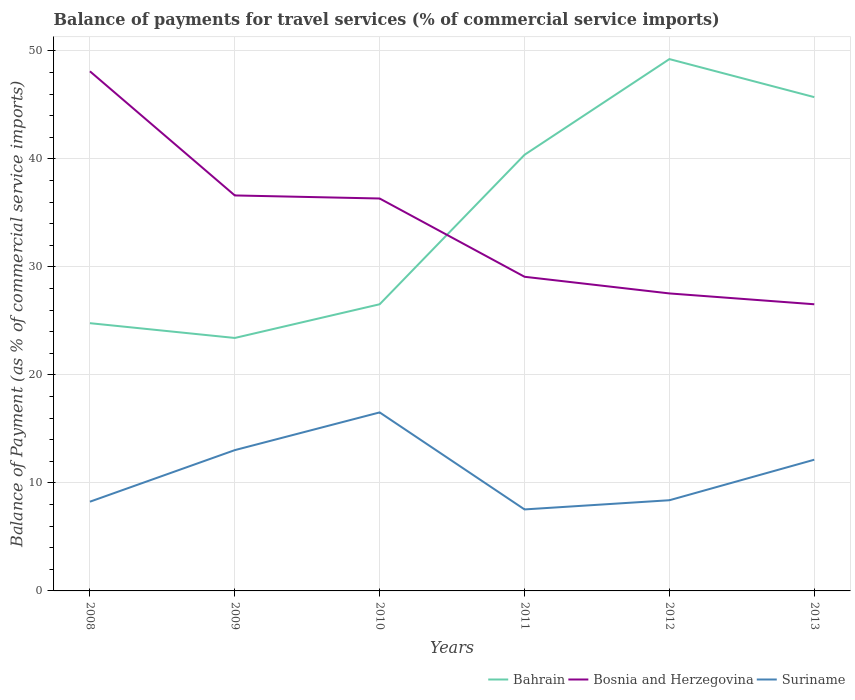Across all years, what is the maximum balance of payments for travel services in Suriname?
Keep it short and to the point. 7.54. What is the total balance of payments for travel services in Bahrain in the graph?
Ensure brevity in your answer.  -22.29. What is the difference between the highest and the second highest balance of payments for travel services in Suriname?
Provide a short and direct response. 8.98. How many lines are there?
Provide a succinct answer. 3. How many years are there in the graph?
Offer a terse response. 6. What is the difference between two consecutive major ticks on the Y-axis?
Make the answer very short. 10. Does the graph contain grids?
Provide a short and direct response. Yes. Where does the legend appear in the graph?
Your response must be concise. Bottom right. How are the legend labels stacked?
Your answer should be compact. Horizontal. What is the title of the graph?
Give a very brief answer. Balance of payments for travel services (% of commercial service imports). Does "Algeria" appear as one of the legend labels in the graph?
Ensure brevity in your answer.  No. What is the label or title of the X-axis?
Your response must be concise. Years. What is the label or title of the Y-axis?
Keep it short and to the point. Balance of Payment (as % of commercial service imports). What is the Balance of Payment (as % of commercial service imports) in Bahrain in 2008?
Provide a succinct answer. 24.79. What is the Balance of Payment (as % of commercial service imports) in Bosnia and Herzegovina in 2008?
Ensure brevity in your answer.  48.11. What is the Balance of Payment (as % of commercial service imports) of Suriname in 2008?
Offer a terse response. 8.26. What is the Balance of Payment (as % of commercial service imports) of Bahrain in 2009?
Offer a terse response. 23.42. What is the Balance of Payment (as % of commercial service imports) of Bosnia and Herzegovina in 2009?
Your answer should be compact. 36.61. What is the Balance of Payment (as % of commercial service imports) of Suriname in 2009?
Provide a succinct answer. 13.03. What is the Balance of Payment (as % of commercial service imports) of Bahrain in 2010?
Your answer should be compact. 26.54. What is the Balance of Payment (as % of commercial service imports) of Bosnia and Herzegovina in 2010?
Offer a very short reply. 36.33. What is the Balance of Payment (as % of commercial service imports) in Suriname in 2010?
Provide a succinct answer. 16.53. What is the Balance of Payment (as % of commercial service imports) of Bahrain in 2011?
Provide a succinct answer. 40.38. What is the Balance of Payment (as % of commercial service imports) in Bosnia and Herzegovina in 2011?
Ensure brevity in your answer.  29.08. What is the Balance of Payment (as % of commercial service imports) in Suriname in 2011?
Offer a terse response. 7.54. What is the Balance of Payment (as % of commercial service imports) in Bahrain in 2012?
Give a very brief answer. 49.24. What is the Balance of Payment (as % of commercial service imports) of Bosnia and Herzegovina in 2012?
Keep it short and to the point. 27.54. What is the Balance of Payment (as % of commercial service imports) of Suriname in 2012?
Offer a very short reply. 8.4. What is the Balance of Payment (as % of commercial service imports) of Bahrain in 2013?
Offer a very short reply. 45.71. What is the Balance of Payment (as % of commercial service imports) of Bosnia and Herzegovina in 2013?
Ensure brevity in your answer.  26.54. What is the Balance of Payment (as % of commercial service imports) of Suriname in 2013?
Ensure brevity in your answer.  12.15. Across all years, what is the maximum Balance of Payment (as % of commercial service imports) in Bahrain?
Offer a very short reply. 49.24. Across all years, what is the maximum Balance of Payment (as % of commercial service imports) of Bosnia and Herzegovina?
Provide a succinct answer. 48.11. Across all years, what is the maximum Balance of Payment (as % of commercial service imports) of Suriname?
Your answer should be very brief. 16.53. Across all years, what is the minimum Balance of Payment (as % of commercial service imports) in Bahrain?
Make the answer very short. 23.42. Across all years, what is the minimum Balance of Payment (as % of commercial service imports) in Bosnia and Herzegovina?
Your response must be concise. 26.54. Across all years, what is the minimum Balance of Payment (as % of commercial service imports) of Suriname?
Provide a succinct answer. 7.54. What is the total Balance of Payment (as % of commercial service imports) of Bahrain in the graph?
Make the answer very short. 210.07. What is the total Balance of Payment (as % of commercial service imports) of Bosnia and Herzegovina in the graph?
Provide a short and direct response. 204.21. What is the total Balance of Payment (as % of commercial service imports) of Suriname in the graph?
Keep it short and to the point. 65.91. What is the difference between the Balance of Payment (as % of commercial service imports) of Bahrain in 2008 and that in 2009?
Offer a very short reply. 1.37. What is the difference between the Balance of Payment (as % of commercial service imports) in Bosnia and Herzegovina in 2008 and that in 2009?
Make the answer very short. 11.49. What is the difference between the Balance of Payment (as % of commercial service imports) of Suriname in 2008 and that in 2009?
Provide a short and direct response. -4.77. What is the difference between the Balance of Payment (as % of commercial service imports) of Bahrain in 2008 and that in 2010?
Your answer should be very brief. -1.75. What is the difference between the Balance of Payment (as % of commercial service imports) in Bosnia and Herzegovina in 2008 and that in 2010?
Your answer should be compact. 11.78. What is the difference between the Balance of Payment (as % of commercial service imports) of Suriname in 2008 and that in 2010?
Your answer should be very brief. -8.27. What is the difference between the Balance of Payment (as % of commercial service imports) in Bahrain in 2008 and that in 2011?
Provide a short and direct response. -15.59. What is the difference between the Balance of Payment (as % of commercial service imports) in Bosnia and Herzegovina in 2008 and that in 2011?
Give a very brief answer. 19.02. What is the difference between the Balance of Payment (as % of commercial service imports) in Suriname in 2008 and that in 2011?
Your response must be concise. 0.72. What is the difference between the Balance of Payment (as % of commercial service imports) of Bahrain in 2008 and that in 2012?
Make the answer very short. -24.45. What is the difference between the Balance of Payment (as % of commercial service imports) in Bosnia and Herzegovina in 2008 and that in 2012?
Your response must be concise. 20.56. What is the difference between the Balance of Payment (as % of commercial service imports) of Suriname in 2008 and that in 2012?
Offer a very short reply. -0.13. What is the difference between the Balance of Payment (as % of commercial service imports) of Bahrain in 2008 and that in 2013?
Your answer should be compact. -20.93. What is the difference between the Balance of Payment (as % of commercial service imports) in Bosnia and Herzegovina in 2008 and that in 2013?
Your response must be concise. 21.57. What is the difference between the Balance of Payment (as % of commercial service imports) of Suriname in 2008 and that in 2013?
Provide a short and direct response. -3.89. What is the difference between the Balance of Payment (as % of commercial service imports) of Bahrain in 2009 and that in 2010?
Give a very brief answer. -3.12. What is the difference between the Balance of Payment (as % of commercial service imports) of Bosnia and Herzegovina in 2009 and that in 2010?
Give a very brief answer. 0.28. What is the difference between the Balance of Payment (as % of commercial service imports) in Suriname in 2009 and that in 2010?
Ensure brevity in your answer.  -3.49. What is the difference between the Balance of Payment (as % of commercial service imports) of Bahrain in 2009 and that in 2011?
Your answer should be very brief. -16.96. What is the difference between the Balance of Payment (as % of commercial service imports) of Bosnia and Herzegovina in 2009 and that in 2011?
Your answer should be very brief. 7.53. What is the difference between the Balance of Payment (as % of commercial service imports) of Suriname in 2009 and that in 2011?
Give a very brief answer. 5.49. What is the difference between the Balance of Payment (as % of commercial service imports) of Bahrain in 2009 and that in 2012?
Your answer should be very brief. -25.82. What is the difference between the Balance of Payment (as % of commercial service imports) of Bosnia and Herzegovina in 2009 and that in 2012?
Ensure brevity in your answer.  9.07. What is the difference between the Balance of Payment (as % of commercial service imports) of Suriname in 2009 and that in 2012?
Your response must be concise. 4.64. What is the difference between the Balance of Payment (as % of commercial service imports) in Bahrain in 2009 and that in 2013?
Your answer should be compact. -22.29. What is the difference between the Balance of Payment (as % of commercial service imports) in Bosnia and Herzegovina in 2009 and that in 2013?
Keep it short and to the point. 10.07. What is the difference between the Balance of Payment (as % of commercial service imports) in Suriname in 2009 and that in 2013?
Provide a short and direct response. 0.89. What is the difference between the Balance of Payment (as % of commercial service imports) in Bahrain in 2010 and that in 2011?
Offer a terse response. -13.84. What is the difference between the Balance of Payment (as % of commercial service imports) of Bosnia and Herzegovina in 2010 and that in 2011?
Make the answer very short. 7.25. What is the difference between the Balance of Payment (as % of commercial service imports) in Suriname in 2010 and that in 2011?
Make the answer very short. 8.98. What is the difference between the Balance of Payment (as % of commercial service imports) of Bahrain in 2010 and that in 2012?
Provide a short and direct response. -22.7. What is the difference between the Balance of Payment (as % of commercial service imports) in Bosnia and Herzegovina in 2010 and that in 2012?
Ensure brevity in your answer.  8.79. What is the difference between the Balance of Payment (as % of commercial service imports) of Suriname in 2010 and that in 2012?
Provide a short and direct response. 8.13. What is the difference between the Balance of Payment (as % of commercial service imports) in Bahrain in 2010 and that in 2013?
Offer a very short reply. -19.17. What is the difference between the Balance of Payment (as % of commercial service imports) in Bosnia and Herzegovina in 2010 and that in 2013?
Provide a short and direct response. 9.79. What is the difference between the Balance of Payment (as % of commercial service imports) in Suriname in 2010 and that in 2013?
Your answer should be compact. 4.38. What is the difference between the Balance of Payment (as % of commercial service imports) of Bahrain in 2011 and that in 2012?
Provide a succinct answer. -8.86. What is the difference between the Balance of Payment (as % of commercial service imports) of Bosnia and Herzegovina in 2011 and that in 2012?
Your response must be concise. 1.54. What is the difference between the Balance of Payment (as % of commercial service imports) of Suriname in 2011 and that in 2012?
Make the answer very short. -0.85. What is the difference between the Balance of Payment (as % of commercial service imports) in Bahrain in 2011 and that in 2013?
Make the answer very short. -5.34. What is the difference between the Balance of Payment (as % of commercial service imports) in Bosnia and Herzegovina in 2011 and that in 2013?
Offer a very short reply. 2.55. What is the difference between the Balance of Payment (as % of commercial service imports) of Suriname in 2011 and that in 2013?
Make the answer very short. -4.6. What is the difference between the Balance of Payment (as % of commercial service imports) in Bahrain in 2012 and that in 2013?
Your answer should be compact. 3.52. What is the difference between the Balance of Payment (as % of commercial service imports) of Suriname in 2012 and that in 2013?
Make the answer very short. -3.75. What is the difference between the Balance of Payment (as % of commercial service imports) of Bahrain in 2008 and the Balance of Payment (as % of commercial service imports) of Bosnia and Herzegovina in 2009?
Ensure brevity in your answer.  -11.83. What is the difference between the Balance of Payment (as % of commercial service imports) of Bahrain in 2008 and the Balance of Payment (as % of commercial service imports) of Suriname in 2009?
Ensure brevity in your answer.  11.75. What is the difference between the Balance of Payment (as % of commercial service imports) of Bosnia and Herzegovina in 2008 and the Balance of Payment (as % of commercial service imports) of Suriname in 2009?
Offer a terse response. 35.07. What is the difference between the Balance of Payment (as % of commercial service imports) of Bahrain in 2008 and the Balance of Payment (as % of commercial service imports) of Bosnia and Herzegovina in 2010?
Your answer should be compact. -11.54. What is the difference between the Balance of Payment (as % of commercial service imports) in Bahrain in 2008 and the Balance of Payment (as % of commercial service imports) in Suriname in 2010?
Your answer should be very brief. 8.26. What is the difference between the Balance of Payment (as % of commercial service imports) of Bosnia and Herzegovina in 2008 and the Balance of Payment (as % of commercial service imports) of Suriname in 2010?
Provide a short and direct response. 31.58. What is the difference between the Balance of Payment (as % of commercial service imports) of Bahrain in 2008 and the Balance of Payment (as % of commercial service imports) of Bosnia and Herzegovina in 2011?
Make the answer very short. -4.3. What is the difference between the Balance of Payment (as % of commercial service imports) of Bahrain in 2008 and the Balance of Payment (as % of commercial service imports) of Suriname in 2011?
Offer a very short reply. 17.24. What is the difference between the Balance of Payment (as % of commercial service imports) of Bosnia and Herzegovina in 2008 and the Balance of Payment (as % of commercial service imports) of Suriname in 2011?
Keep it short and to the point. 40.56. What is the difference between the Balance of Payment (as % of commercial service imports) in Bahrain in 2008 and the Balance of Payment (as % of commercial service imports) in Bosnia and Herzegovina in 2012?
Offer a terse response. -2.75. What is the difference between the Balance of Payment (as % of commercial service imports) in Bahrain in 2008 and the Balance of Payment (as % of commercial service imports) in Suriname in 2012?
Provide a short and direct response. 16.39. What is the difference between the Balance of Payment (as % of commercial service imports) in Bosnia and Herzegovina in 2008 and the Balance of Payment (as % of commercial service imports) in Suriname in 2012?
Offer a terse response. 39.71. What is the difference between the Balance of Payment (as % of commercial service imports) of Bahrain in 2008 and the Balance of Payment (as % of commercial service imports) of Bosnia and Herzegovina in 2013?
Offer a terse response. -1.75. What is the difference between the Balance of Payment (as % of commercial service imports) in Bahrain in 2008 and the Balance of Payment (as % of commercial service imports) in Suriname in 2013?
Ensure brevity in your answer.  12.64. What is the difference between the Balance of Payment (as % of commercial service imports) in Bosnia and Herzegovina in 2008 and the Balance of Payment (as % of commercial service imports) in Suriname in 2013?
Provide a succinct answer. 35.96. What is the difference between the Balance of Payment (as % of commercial service imports) in Bahrain in 2009 and the Balance of Payment (as % of commercial service imports) in Bosnia and Herzegovina in 2010?
Provide a short and direct response. -12.91. What is the difference between the Balance of Payment (as % of commercial service imports) of Bahrain in 2009 and the Balance of Payment (as % of commercial service imports) of Suriname in 2010?
Provide a short and direct response. 6.89. What is the difference between the Balance of Payment (as % of commercial service imports) in Bosnia and Herzegovina in 2009 and the Balance of Payment (as % of commercial service imports) in Suriname in 2010?
Your answer should be compact. 20.09. What is the difference between the Balance of Payment (as % of commercial service imports) in Bahrain in 2009 and the Balance of Payment (as % of commercial service imports) in Bosnia and Herzegovina in 2011?
Offer a terse response. -5.67. What is the difference between the Balance of Payment (as % of commercial service imports) in Bahrain in 2009 and the Balance of Payment (as % of commercial service imports) in Suriname in 2011?
Provide a short and direct response. 15.87. What is the difference between the Balance of Payment (as % of commercial service imports) of Bosnia and Herzegovina in 2009 and the Balance of Payment (as % of commercial service imports) of Suriname in 2011?
Provide a short and direct response. 29.07. What is the difference between the Balance of Payment (as % of commercial service imports) of Bahrain in 2009 and the Balance of Payment (as % of commercial service imports) of Bosnia and Herzegovina in 2012?
Give a very brief answer. -4.12. What is the difference between the Balance of Payment (as % of commercial service imports) in Bahrain in 2009 and the Balance of Payment (as % of commercial service imports) in Suriname in 2012?
Your answer should be very brief. 15.02. What is the difference between the Balance of Payment (as % of commercial service imports) in Bosnia and Herzegovina in 2009 and the Balance of Payment (as % of commercial service imports) in Suriname in 2012?
Offer a very short reply. 28.22. What is the difference between the Balance of Payment (as % of commercial service imports) of Bahrain in 2009 and the Balance of Payment (as % of commercial service imports) of Bosnia and Herzegovina in 2013?
Make the answer very short. -3.12. What is the difference between the Balance of Payment (as % of commercial service imports) in Bahrain in 2009 and the Balance of Payment (as % of commercial service imports) in Suriname in 2013?
Ensure brevity in your answer.  11.27. What is the difference between the Balance of Payment (as % of commercial service imports) in Bosnia and Herzegovina in 2009 and the Balance of Payment (as % of commercial service imports) in Suriname in 2013?
Your response must be concise. 24.47. What is the difference between the Balance of Payment (as % of commercial service imports) in Bahrain in 2010 and the Balance of Payment (as % of commercial service imports) in Bosnia and Herzegovina in 2011?
Your answer should be compact. -2.54. What is the difference between the Balance of Payment (as % of commercial service imports) in Bahrain in 2010 and the Balance of Payment (as % of commercial service imports) in Suriname in 2011?
Make the answer very short. 18.99. What is the difference between the Balance of Payment (as % of commercial service imports) in Bosnia and Herzegovina in 2010 and the Balance of Payment (as % of commercial service imports) in Suriname in 2011?
Provide a short and direct response. 28.78. What is the difference between the Balance of Payment (as % of commercial service imports) of Bahrain in 2010 and the Balance of Payment (as % of commercial service imports) of Bosnia and Herzegovina in 2012?
Offer a very short reply. -1. What is the difference between the Balance of Payment (as % of commercial service imports) in Bahrain in 2010 and the Balance of Payment (as % of commercial service imports) in Suriname in 2012?
Ensure brevity in your answer.  18.14. What is the difference between the Balance of Payment (as % of commercial service imports) of Bosnia and Herzegovina in 2010 and the Balance of Payment (as % of commercial service imports) of Suriname in 2012?
Make the answer very short. 27.93. What is the difference between the Balance of Payment (as % of commercial service imports) of Bahrain in 2010 and the Balance of Payment (as % of commercial service imports) of Bosnia and Herzegovina in 2013?
Your answer should be compact. 0. What is the difference between the Balance of Payment (as % of commercial service imports) of Bahrain in 2010 and the Balance of Payment (as % of commercial service imports) of Suriname in 2013?
Make the answer very short. 14.39. What is the difference between the Balance of Payment (as % of commercial service imports) of Bosnia and Herzegovina in 2010 and the Balance of Payment (as % of commercial service imports) of Suriname in 2013?
Offer a terse response. 24.18. What is the difference between the Balance of Payment (as % of commercial service imports) of Bahrain in 2011 and the Balance of Payment (as % of commercial service imports) of Bosnia and Herzegovina in 2012?
Make the answer very short. 12.84. What is the difference between the Balance of Payment (as % of commercial service imports) in Bahrain in 2011 and the Balance of Payment (as % of commercial service imports) in Suriname in 2012?
Provide a succinct answer. 31.98. What is the difference between the Balance of Payment (as % of commercial service imports) of Bosnia and Herzegovina in 2011 and the Balance of Payment (as % of commercial service imports) of Suriname in 2012?
Your answer should be compact. 20.69. What is the difference between the Balance of Payment (as % of commercial service imports) in Bahrain in 2011 and the Balance of Payment (as % of commercial service imports) in Bosnia and Herzegovina in 2013?
Your answer should be very brief. 13.84. What is the difference between the Balance of Payment (as % of commercial service imports) in Bahrain in 2011 and the Balance of Payment (as % of commercial service imports) in Suriname in 2013?
Ensure brevity in your answer.  28.23. What is the difference between the Balance of Payment (as % of commercial service imports) of Bosnia and Herzegovina in 2011 and the Balance of Payment (as % of commercial service imports) of Suriname in 2013?
Ensure brevity in your answer.  16.94. What is the difference between the Balance of Payment (as % of commercial service imports) of Bahrain in 2012 and the Balance of Payment (as % of commercial service imports) of Bosnia and Herzegovina in 2013?
Provide a short and direct response. 22.7. What is the difference between the Balance of Payment (as % of commercial service imports) in Bahrain in 2012 and the Balance of Payment (as % of commercial service imports) in Suriname in 2013?
Provide a short and direct response. 37.09. What is the difference between the Balance of Payment (as % of commercial service imports) of Bosnia and Herzegovina in 2012 and the Balance of Payment (as % of commercial service imports) of Suriname in 2013?
Make the answer very short. 15.39. What is the average Balance of Payment (as % of commercial service imports) of Bahrain per year?
Your answer should be compact. 35.01. What is the average Balance of Payment (as % of commercial service imports) of Bosnia and Herzegovina per year?
Ensure brevity in your answer.  34.04. What is the average Balance of Payment (as % of commercial service imports) of Suriname per year?
Ensure brevity in your answer.  10.98. In the year 2008, what is the difference between the Balance of Payment (as % of commercial service imports) in Bahrain and Balance of Payment (as % of commercial service imports) in Bosnia and Herzegovina?
Provide a short and direct response. -23.32. In the year 2008, what is the difference between the Balance of Payment (as % of commercial service imports) of Bahrain and Balance of Payment (as % of commercial service imports) of Suriname?
Your answer should be very brief. 16.53. In the year 2008, what is the difference between the Balance of Payment (as % of commercial service imports) of Bosnia and Herzegovina and Balance of Payment (as % of commercial service imports) of Suriname?
Provide a short and direct response. 39.85. In the year 2009, what is the difference between the Balance of Payment (as % of commercial service imports) in Bahrain and Balance of Payment (as % of commercial service imports) in Bosnia and Herzegovina?
Keep it short and to the point. -13.19. In the year 2009, what is the difference between the Balance of Payment (as % of commercial service imports) of Bahrain and Balance of Payment (as % of commercial service imports) of Suriname?
Your response must be concise. 10.38. In the year 2009, what is the difference between the Balance of Payment (as % of commercial service imports) in Bosnia and Herzegovina and Balance of Payment (as % of commercial service imports) in Suriname?
Make the answer very short. 23.58. In the year 2010, what is the difference between the Balance of Payment (as % of commercial service imports) in Bahrain and Balance of Payment (as % of commercial service imports) in Bosnia and Herzegovina?
Make the answer very short. -9.79. In the year 2010, what is the difference between the Balance of Payment (as % of commercial service imports) in Bahrain and Balance of Payment (as % of commercial service imports) in Suriname?
Your answer should be compact. 10.01. In the year 2010, what is the difference between the Balance of Payment (as % of commercial service imports) of Bosnia and Herzegovina and Balance of Payment (as % of commercial service imports) of Suriname?
Offer a very short reply. 19.8. In the year 2011, what is the difference between the Balance of Payment (as % of commercial service imports) of Bahrain and Balance of Payment (as % of commercial service imports) of Bosnia and Herzegovina?
Make the answer very short. 11.29. In the year 2011, what is the difference between the Balance of Payment (as % of commercial service imports) in Bahrain and Balance of Payment (as % of commercial service imports) in Suriname?
Your answer should be compact. 32.83. In the year 2011, what is the difference between the Balance of Payment (as % of commercial service imports) of Bosnia and Herzegovina and Balance of Payment (as % of commercial service imports) of Suriname?
Provide a short and direct response. 21.54. In the year 2012, what is the difference between the Balance of Payment (as % of commercial service imports) in Bahrain and Balance of Payment (as % of commercial service imports) in Bosnia and Herzegovina?
Offer a terse response. 21.69. In the year 2012, what is the difference between the Balance of Payment (as % of commercial service imports) of Bahrain and Balance of Payment (as % of commercial service imports) of Suriname?
Offer a very short reply. 40.84. In the year 2012, what is the difference between the Balance of Payment (as % of commercial service imports) in Bosnia and Herzegovina and Balance of Payment (as % of commercial service imports) in Suriname?
Provide a succinct answer. 19.15. In the year 2013, what is the difference between the Balance of Payment (as % of commercial service imports) in Bahrain and Balance of Payment (as % of commercial service imports) in Bosnia and Herzegovina?
Your answer should be very brief. 19.17. In the year 2013, what is the difference between the Balance of Payment (as % of commercial service imports) of Bahrain and Balance of Payment (as % of commercial service imports) of Suriname?
Your response must be concise. 33.57. In the year 2013, what is the difference between the Balance of Payment (as % of commercial service imports) in Bosnia and Herzegovina and Balance of Payment (as % of commercial service imports) in Suriname?
Provide a short and direct response. 14.39. What is the ratio of the Balance of Payment (as % of commercial service imports) in Bahrain in 2008 to that in 2009?
Your answer should be compact. 1.06. What is the ratio of the Balance of Payment (as % of commercial service imports) of Bosnia and Herzegovina in 2008 to that in 2009?
Your answer should be compact. 1.31. What is the ratio of the Balance of Payment (as % of commercial service imports) in Suriname in 2008 to that in 2009?
Ensure brevity in your answer.  0.63. What is the ratio of the Balance of Payment (as % of commercial service imports) of Bahrain in 2008 to that in 2010?
Your answer should be compact. 0.93. What is the ratio of the Balance of Payment (as % of commercial service imports) in Bosnia and Herzegovina in 2008 to that in 2010?
Provide a short and direct response. 1.32. What is the ratio of the Balance of Payment (as % of commercial service imports) in Suriname in 2008 to that in 2010?
Make the answer very short. 0.5. What is the ratio of the Balance of Payment (as % of commercial service imports) of Bahrain in 2008 to that in 2011?
Ensure brevity in your answer.  0.61. What is the ratio of the Balance of Payment (as % of commercial service imports) of Bosnia and Herzegovina in 2008 to that in 2011?
Ensure brevity in your answer.  1.65. What is the ratio of the Balance of Payment (as % of commercial service imports) in Suriname in 2008 to that in 2011?
Make the answer very short. 1.09. What is the ratio of the Balance of Payment (as % of commercial service imports) in Bahrain in 2008 to that in 2012?
Give a very brief answer. 0.5. What is the ratio of the Balance of Payment (as % of commercial service imports) of Bosnia and Herzegovina in 2008 to that in 2012?
Give a very brief answer. 1.75. What is the ratio of the Balance of Payment (as % of commercial service imports) in Suriname in 2008 to that in 2012?
Your answer should be very brief. 0.98. What is the ratio of the Balance of Payment (as % of commercial service imports) in Bahrain in 2008 to that in 2013?
Your response must be concise. 0.54. What is the ratio of the Balance of Payment (as % of commercial service imports) of Bosnia and Herzegovina in 2008 to that in 2013?
Your answer should be compact. 1.81. What is the ratio of the Balance of Payment (as % of commercial service imports) in Suriname in 2008 to that in 2013?
Keep it short and to the point. 0.68. What is the ratio of the Balance of Payment (as % of commercial service imports) in Bahrain in 2009 to that in 2010?
Keep it short and to the point. 0.88. What is the ratio of the Balance of Payment (as % of commercial service imports) in Suriname in 2009 to that in 2010?
Your response must be concise. 0.79. What is the ratio of the Balance of Payment (as % of commercial service imports) in Bahrain in 2009 to that in 2011?
Provide a succinct answer. 0.58. What is the ratio of the Balance of Payment (as % of commercial service imports) of Bosnia and Herzegovina in 2009 to that in 2011?
Keep it short and to the point. 1.26. What is the ratio of the Balance of Payment (as % of commercial service imports) of Suriname in 2009 to that in 2011?
Keep it short and to the point. 1.73. What is the ratio of the Balance of Payment (as % of commercial service imports) of Bahrain in 2009 to that in 2012?
Give a very brief answer. 0.48. What is the ratio of the Balance of Payment (as % of commercial service imports) in Bosnia and Herzegovina in 2009 to that in 2012?
Make the answer very short. 1.33. What is the ratio of the Balance of Payment (as % of commercial service imports) of Suriname in 2009 to that in 2012?
Your answer should be very brief. 1.55. What is the ratio of the Balance of Payment (as % of commercial service imports) of Bahrain in 2009 to that in 2013?
Your answer should be compact. 0.51. What is the ratio of the Balance of Payment (as % of commercial service imports) in Bosnia and Herzegovina in 2009 to that in 2013?
Make the answer very short. 1.38. What is the ratio of the Balance of Payment (as % of commercial service imports) of Suriname in 2009 to that in 2013?
Make the answer very short. 1.07. What is the ratio of the Balance of Payment (as % of commercial service imports) of Bahrain in 2010 to that in 2011?
Provide a succinct answer. 0.66. What is the ratio of the Balance of Payment (as % of commercial service imports) of Bosnia and Herzegovina in 2010 to that in 2011?
Your response must be concise. 1.25. What is the ratio of the Balance of Payment (as % of commercial service imports) in Suriname in 2010 to that in 2011?
Ensure brevity in your answer.  2.19. What is the ratio of the Balance of Payment (as % of commercial service imports) in Bahrain in 2010 to that in 2012?
Make the answer very short. 0.54. What is the ratio of the Balance of Payment (as % of commercial service imports) in Bosnia and Herzegovina in 2010 to that in 2012?
Keep it short and to the point. 1.32. What is the ratio of the Balance of Payment (as % of commercial service imports) of Suriname in 2010 to that in 2012?
Keep it short and to the point. 1.97. What is the ratio of the Balance of Payment (as % of commercial service imports) in Bahrain in 2010 to that in 2013?
Provide a short and direct response. 0.58. What is the ratio of the Balance of Payment (as % of commercial service imports) in Bosnia and Herzegovina in 2010 to that in 2013?
Your response must be concise. 1.37. What is the ratio of the Balance of Payment (as % of commercial service imports) in Suriname in 2010 to that in 2013?
Your response must be concise. 1.36. What is the ratio of the Balance of Payment (as % of commercial service imports) of Bahrain in 2011 to that in 2012?
Offer a very short reply. 0.82. What is the ratio of the Balance of Payment (as % of commercial service imports) in Bosnia and Herzegovina in 2011 to that in 2012?
Provide a succinct answer. 1.06. What is the ratio of the Balance of Payment (as % of commercial service imports) in Suriname in 2011 to that in 2012?
Ensure brevity in your answer.  0.9. What is the ratio of the Balance of Payment (as % of commercial service imports) in Bahrain in 2011 to that in 2013?
Give a very brief answer. 0.88. What is the ratio of the Balance of Payment (as % of commercial service imports) of Bosnia and Herzegovina in 2011 to that in 2013?
Ensure brevity in your answer.  1.1. What is the ratio of the Balance of Payment (as % of commercial service imports) in Suriname in 2011 to that in 2013?
Your answer should be very brief. 0.62. What is the ratio of the Balance of Payment (as % of commercial service imports) of Bahrain in 2012 to that in 2013?
Your answer should be very brief. 1.08. What is the ratio of the Balance of Payment (as % of commercial service imports) of Bosnia and Herzegovina in 2012 to that in 2013?
Provide a short and direct response. 1.04. What is the ratio of the Balance of Payment (as % of commercial service imports) in Suriname in 2012 to that in 2013?
Ensure brevity in your answer.  0.69. What is the difference between the highest and the second highest Balance of Payment (as % of commercial service imports) in Bahrain?
Provide a short and direct response. 3.52. What is the difference between the highest and the second highest Balance of Payment (as % of commercial service imports) of Bosnia and Herzegovina?
Provide a short and direct response. 11.49. What is the difference between the highest and the second highest Balance of Payment (as % of commercial service imports) in Suriname?
Your response must be concise. 3.49. What is the difference between the highest and the lowest Balance of Payment (as % of commercial service imports) of Bahrain?
Keep it short and to the point. 25.82. What is the difference between the highest and the lowest Balance of Payment (as % of commercial service imports) in Bosnia and Herzegovina?
Give a very brief answer. 21.57. What is the difference between the highest and the lowest Balance of Payment (as % of commercial service imports) of Suriname?
Give a very brief answer. 8.98. 